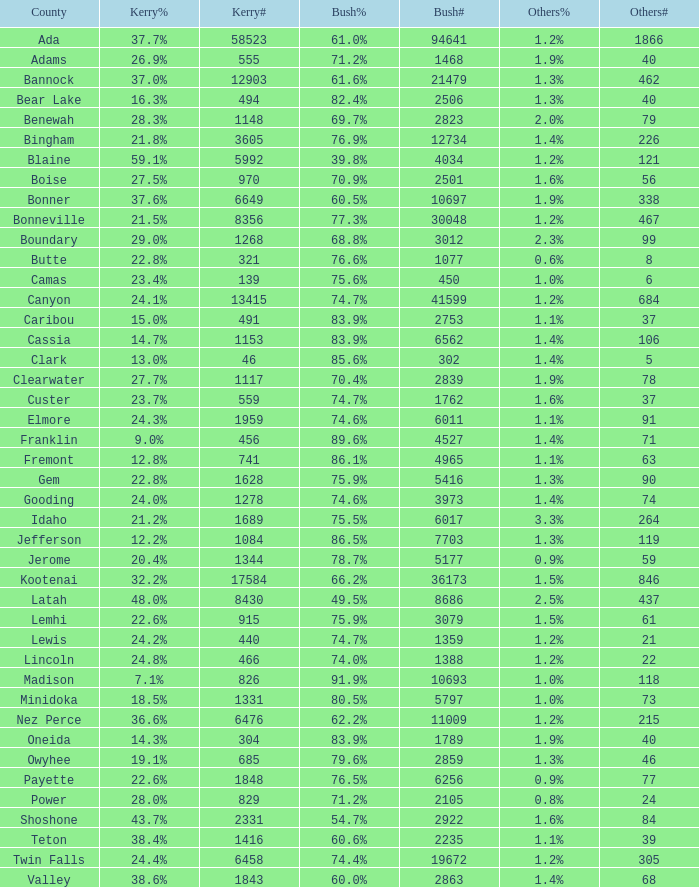What is the number of unique vote counts for bush in the county where he won 6 1.0. 